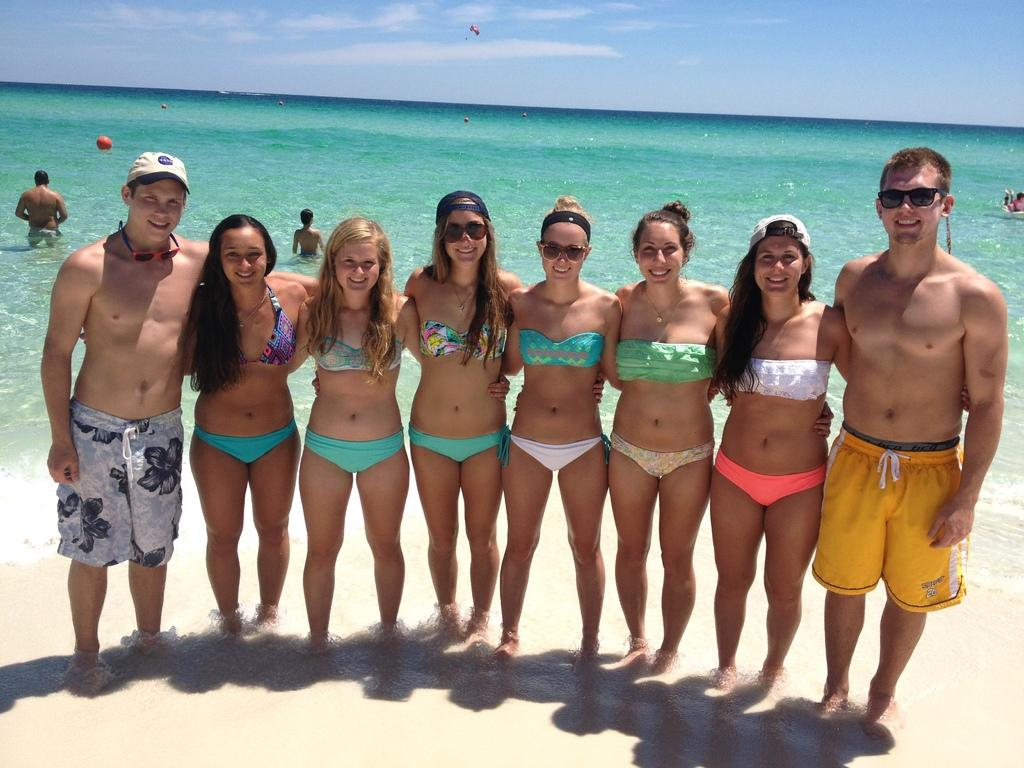What is the primary surface that the persons are standing on in the image? The persons are standing on the sand in the image. What can be seen in the background behind the persons? There is water, persons, a parachute, and the sky visible in the background. What is the condition of the sky in the image? The sky is visible in the background, and clouds are present. What type of guitar can be seen being played by a person in the image? There is no guitar present in the image; the persons are standing on the sand and there are no musical instruments visible. 